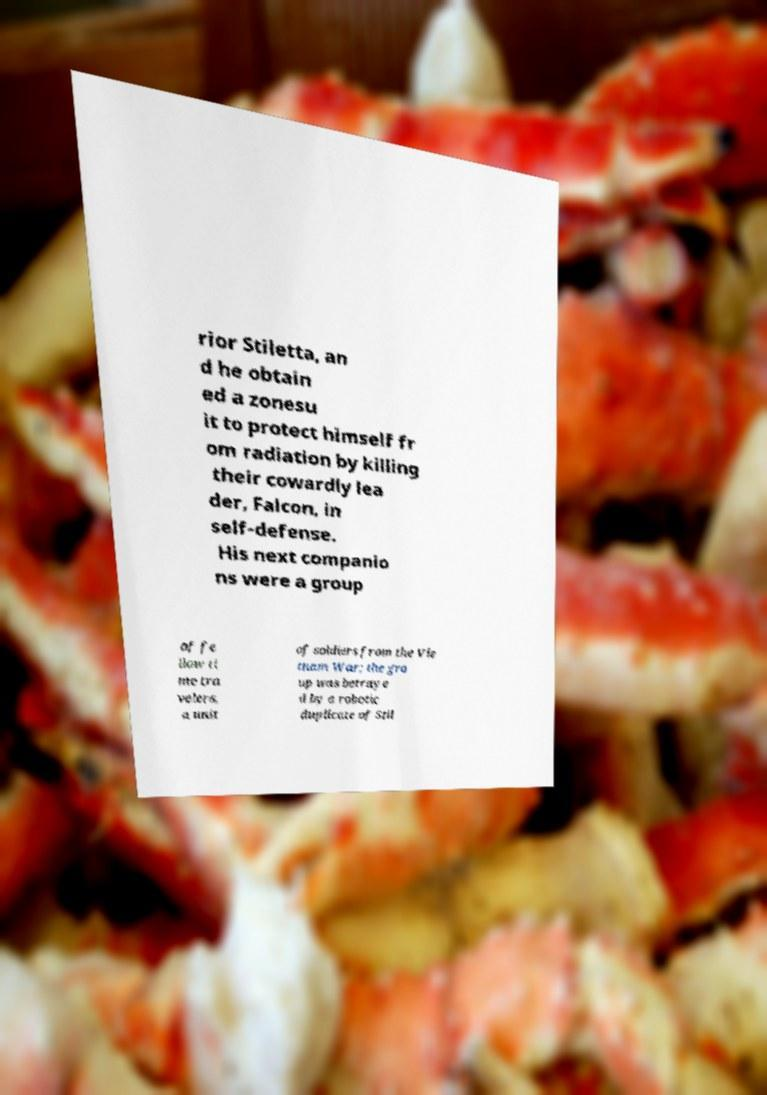Can you read and provide the text displayed in the image?This photo seems to have some interesting text. Can you extract and type it out for me? rior Stiletta, an d he obtain ed a zonesu it to protect himself fr om radiation by killing their cowardly lea der, Falcon, in self-defense. His next companio ns were a group of fe llow ti me tra velers, a unit of soldiers from the Vie tnam War; the gro up was betraye d by a robotic duplicate of Stil 